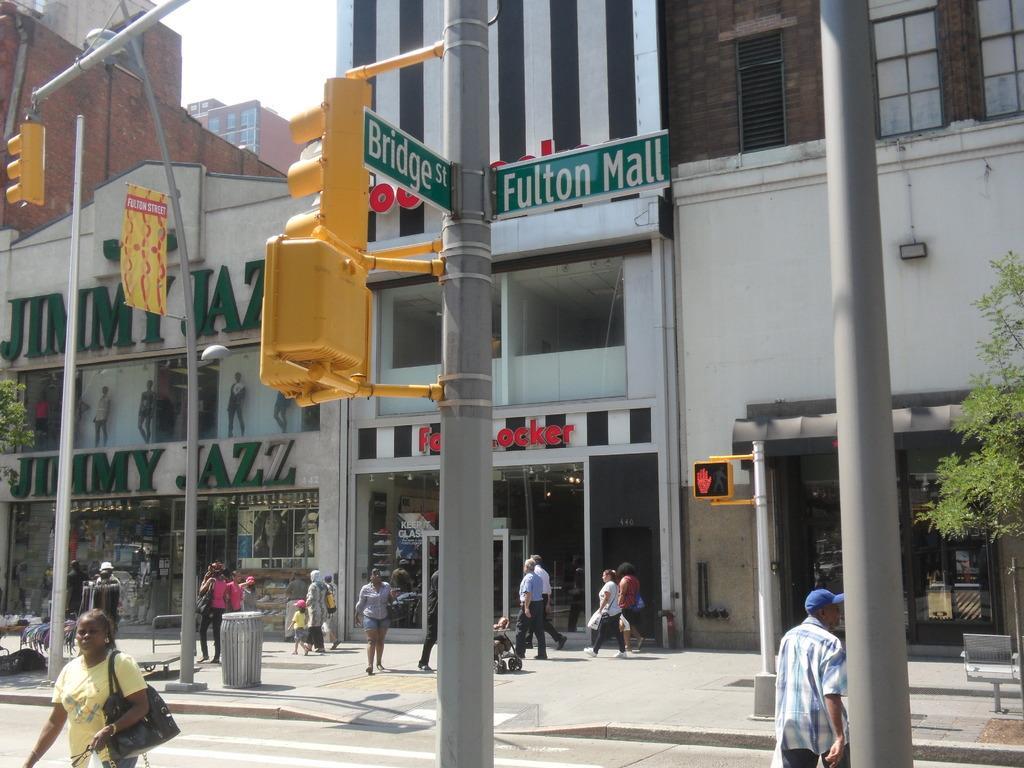How would you summarize this image in a sentence or two? This image is taken outdoors. At the bottom of the image there is a road and there is a sidewalk. In the background there are two buildings with walls, windows, grills, roofs and doors. There are many boards with text on them. On the right side of the image there is a tree and there is an empty bench. There is a pole. There is a signboard and a man is walking on the road. On the left side of the image there is a pole with a signal light and here is a street light. There is a dustbin on the sidewalk. A few people are walking on the sidewalk. In the middle of the image a few are walking. 